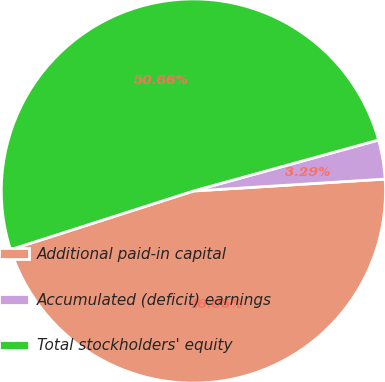Convert chart. <chart><loc_0><loc_0><loc_500><loc_500><pie_chart><fcel>Additional paid-in capital<fcel>Accumulated (deficit) earnings<fcel>Total stockholders' equity<nl><fcel>46.05%<fcel>3.29%<fcel>50.66%<nl></chart> 